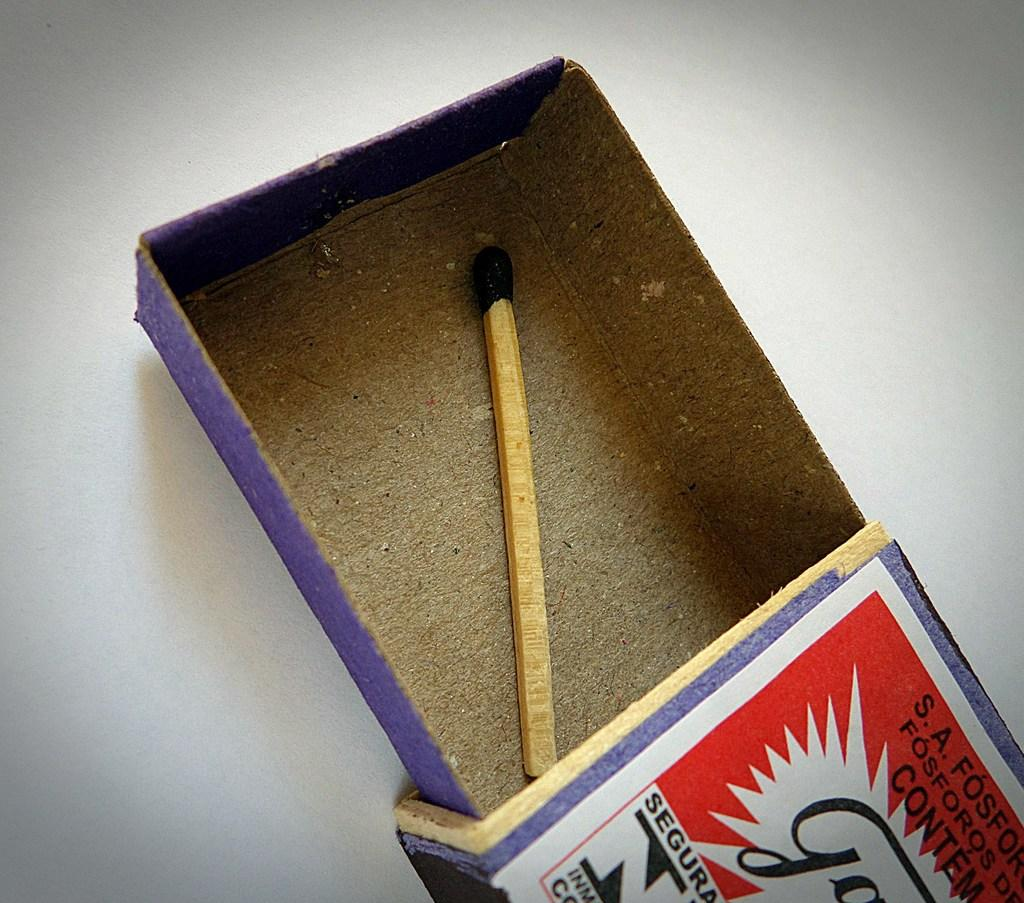<image>
Offer a succinct explanation of the picture presented. A single match is in a match box with FOSFOROS written on the box. 